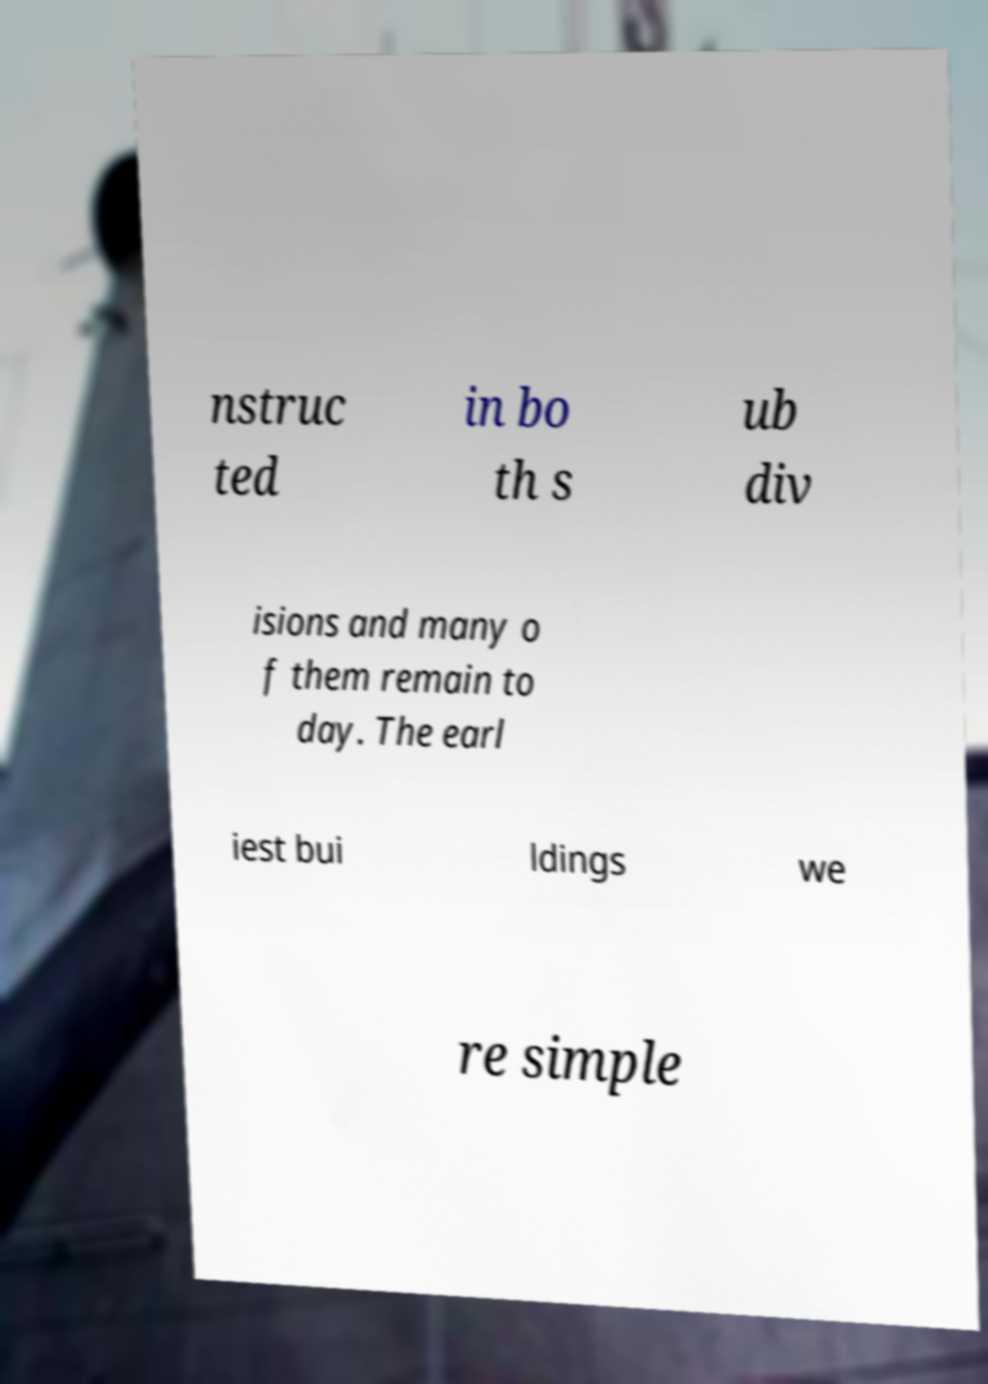Please read and relay the text visible in this image. What does it say? nstruc ted in bo th s ub div isions and many o f them remain to day. The earl iest bui ldings we re simple 